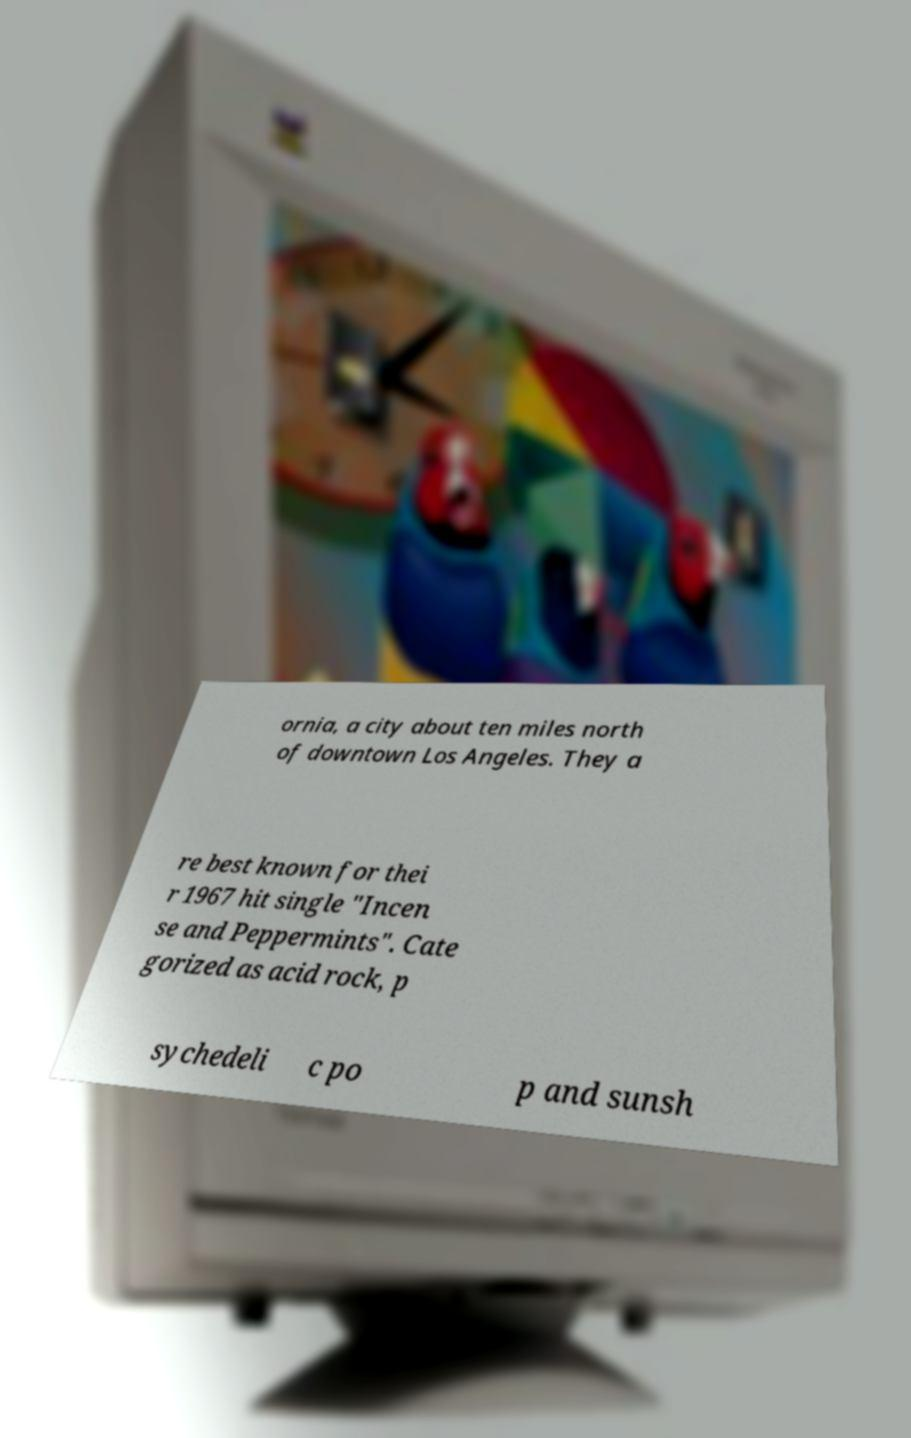Please identify and transcribe the text found in this image. ornia, a city about ten miles north of downtown Los Angeles. They a re best known for thei r 1967 hit single "Incen se and Peppermints". Cate gorized as acid rock, p sychedeli c po p and sunsh 